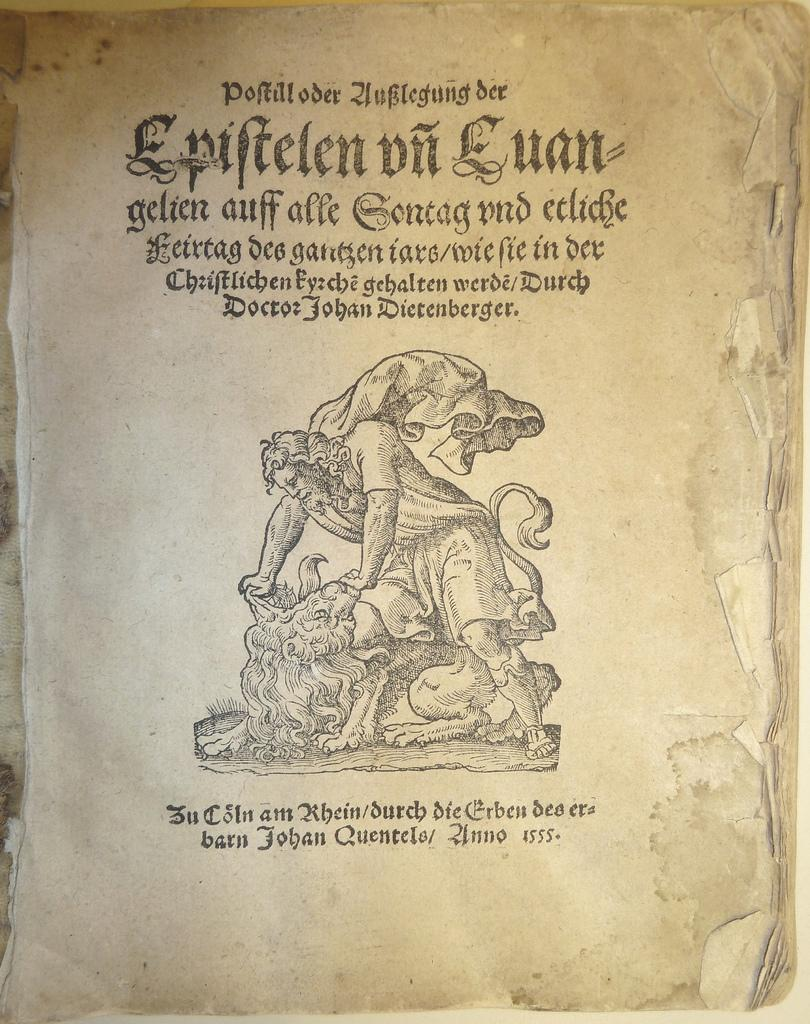<image>
Relay a brief, clear account of the picture shown. A book is opened with the page title Epiftelen on Euan. 